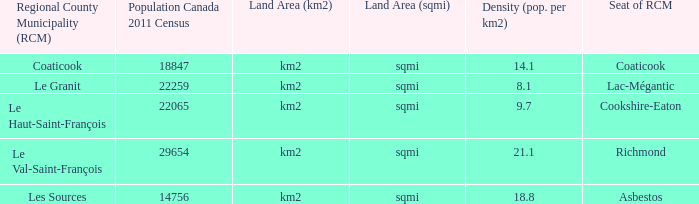Give me the full table as a dictionary. {'header': ['Regional County Municipality (RCM)', 'Population Canada 2011 Census', 'Land Area (km2)', 'Land Area (sqmi)', 'Density (pop. per km2)', 'Seat of RCM'], 'rows': [['Coaticook', '18847', 'km2', 'sqmi', '14.1', 'Coaticook'], ['Le Granit', '22259', 'km2', 'sqmi', '8.1', 'Lac-Mégantic'], ['Le Haut-Saint-François', '22065', 'km2', 'sqmi', '9.7', 'Cookshire-Eaton'], ['Le Val-Saint-François', '29654', 'km2', 'sqmi', '21.1', 'Richmond'], ['Les Sources', '14756', 'km2', 'sqmi', '18.8', 'Asbestos']]} What is the county seat with a population density of 1 Coaticook. 